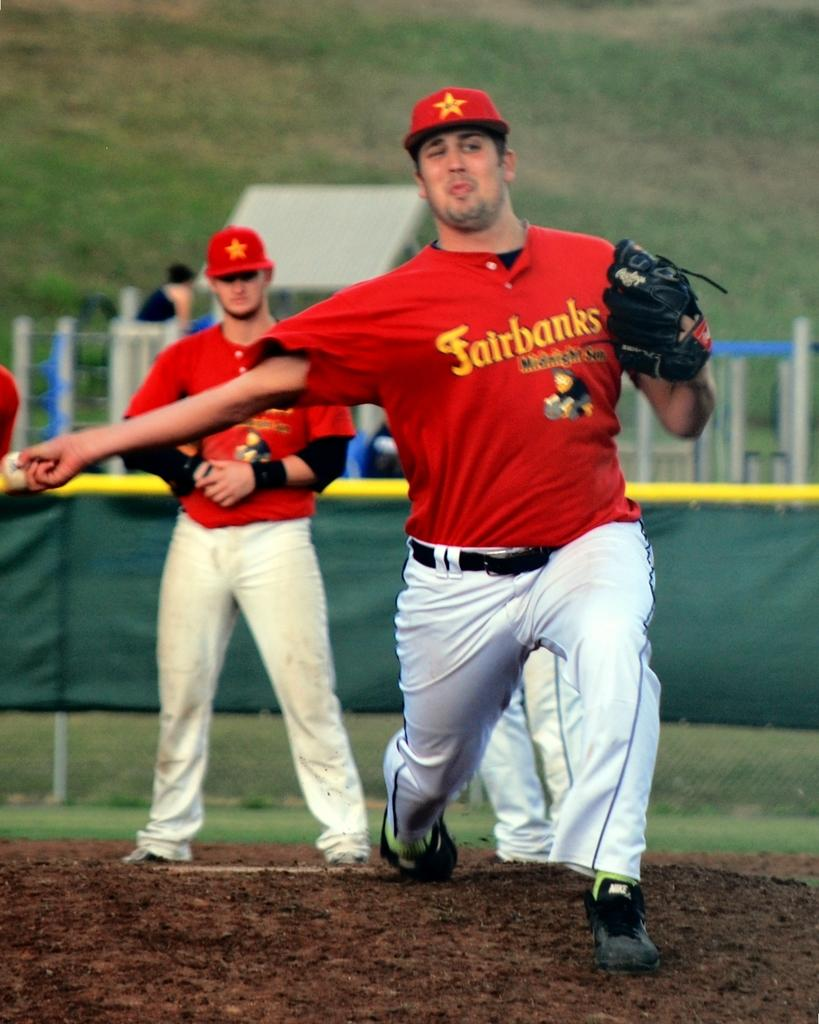<image>
Provide a brief description of the given image. a baseball player with a red shirt that says fairbanks midnight sun on it 